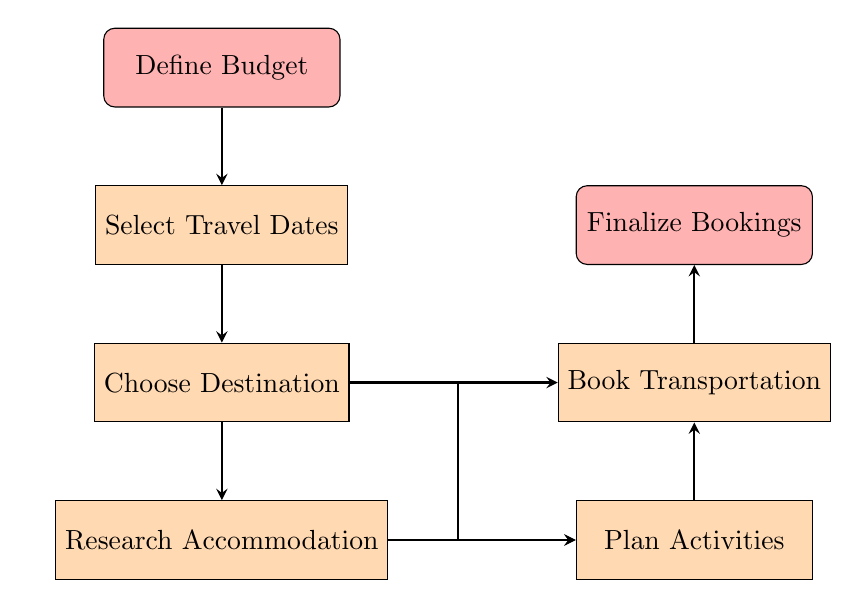What is the first step in the process? The flow chart indicates that the first node in the process is "Define Budget," which is the starting point of planning the holiday.
Answer: Define Budget How many total nodes are present in the diagram? By counting the nodes listed in the flow chart, there are six distinct nodes, which include "Define Budget," "Select Travel Dates," "Choose Destination," "Research Accommodation," "Plan Activities," and "Book Transportation," leading to the end node "Finalize Bookings."
Answer: 7 Which node comes after 'Choose Destination'? The flow chart shows an arrow directed from "Choose Destination" to "Research Accommodation," indicating that it is the immediate next step following the selection of a destination.
Answer: Research Accommodation What are the two activities that can be planned according to the flow chart? The diagram lists four possible activities, but the visitors only need to select two based on their interest; therefore, they can choose any two from "Sightseeing Tours," "Cultural Experiences," "Whisky Tastings," and "Scenic Drives."
Answer: Any two activities Which node has a connection to both 'Activities' and 'Transportation'? The "Choose Destination" node branches out and has arrows leading to both "Plan Activities" and "Book Transportation," indicating that this step influences both the planning of activities and transportation arrangements.
Answer: Choose Destination What is the last step before finalizing bookings? The last node prior to "Finalize Bookings" is "Book Transportation," meaning that transportation arrangements must be made before confirming all bookings.
Answer: Book Transportation Are there any reverse paths in the flow chart? No, the flow chart is structured in a linear manner with all arrows pointing in one direction from the start to the end, which illustrates a clear sequence without any reverse paths possible.
Answer: No What node follows 'Research Accommodation' in the process? After "Research Accommodation," the flow chart shows a direct connection to "Plan Activities," indicating that researching places to stay occurs before planning activities.
Answer: Plan Activities 